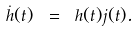Convert formula to latex. <formula><loc_0><loc_0><loc_500><loc_500>\dot { h } ( t ) \ = \ h ( t ) j ( t ) .</formula> 